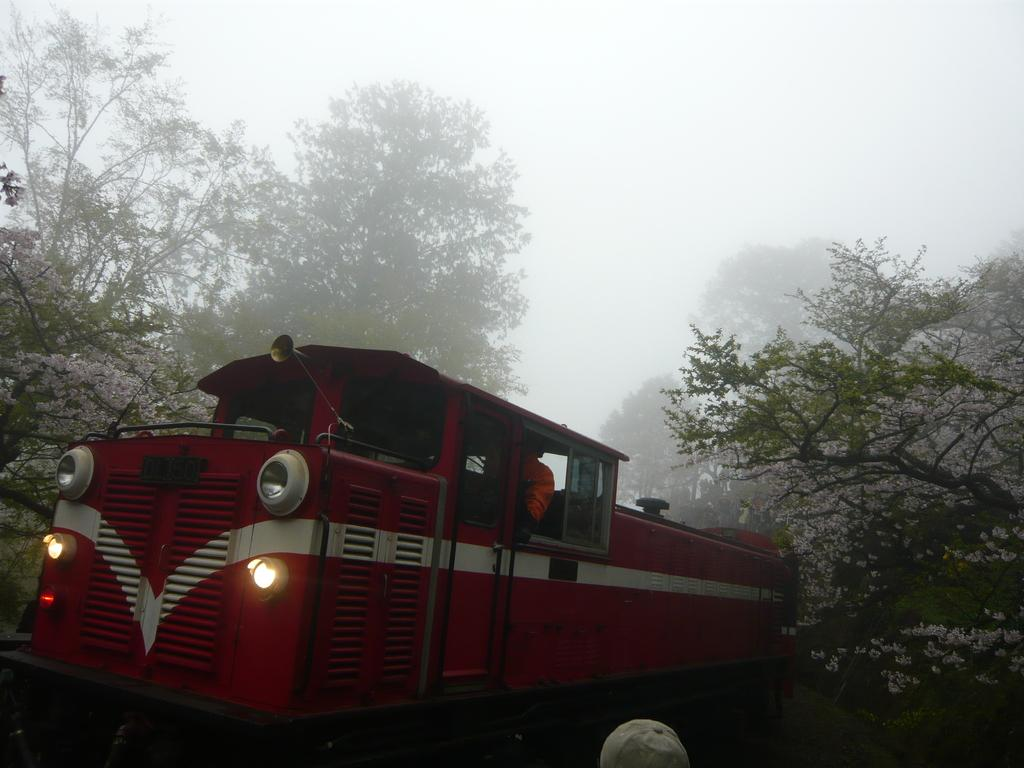What is the main subject in the middle of the image? There is a train in the middle of the image. What specific feature can be observed on the train? The train has two headlights. What type of natural scenery is visible in the background of the image? There are trees in the background of the image. What is present at the bottom of the image? There is a cap at the bottom of the image. What atmospheric condition is visible at the top of the image? There is fog at the top of the image. What type of disease is affecting the bird in the image? There is no bird present in the image, so it is not possible to determine if a disease is affecting any bird. 